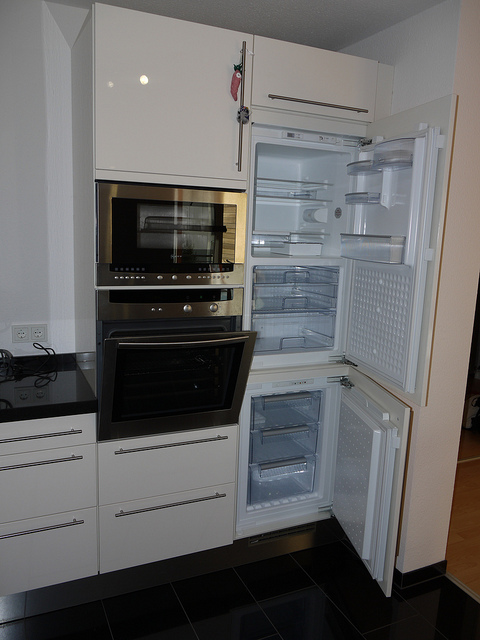<image>What is in the oven? I don't know what is in the oven. It could be empty or there could be something like bread or pizza baking. What is behind the closed doors? It is unknown what is behind the closed doors. It could be nothing or there could be a fridge or kitchen stuff. What patterns are on the floor? I am not sure about the pattern on the floor. It could be squares or simply no pattern. What is in the oven? I don't know what is in the oven. It can be nothing, bread, something baking or pizza. What is behind the closed doors? It is unknown what is behind the closed doors. It can be nothing or some objects related to the kitchen. What patterns are on the floor? I don't know what patterns are on the floor. It can be squares or black tiles. 